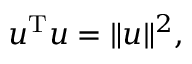Convert formula to latex. <formula><loc_0><loc_0><loc_500><loc_500>u ^ { T } u = \| u \| ^ { 2 } ,</formula> 